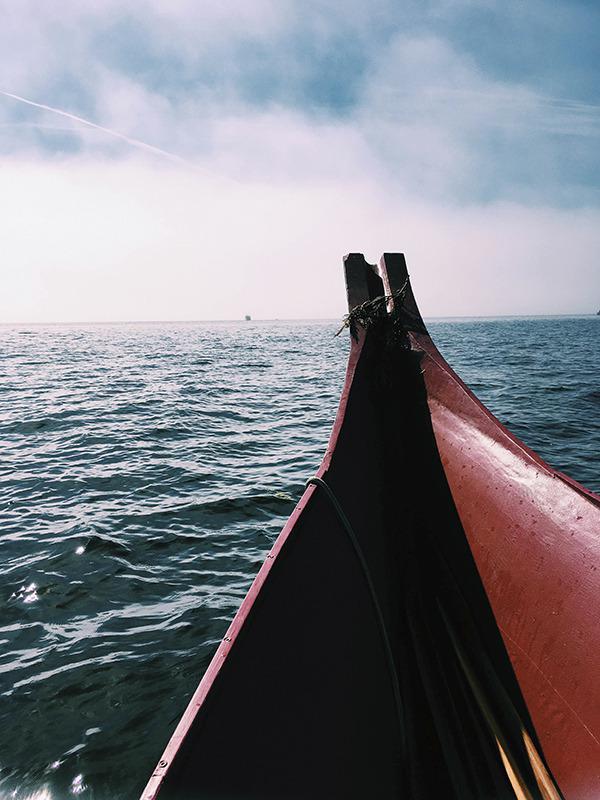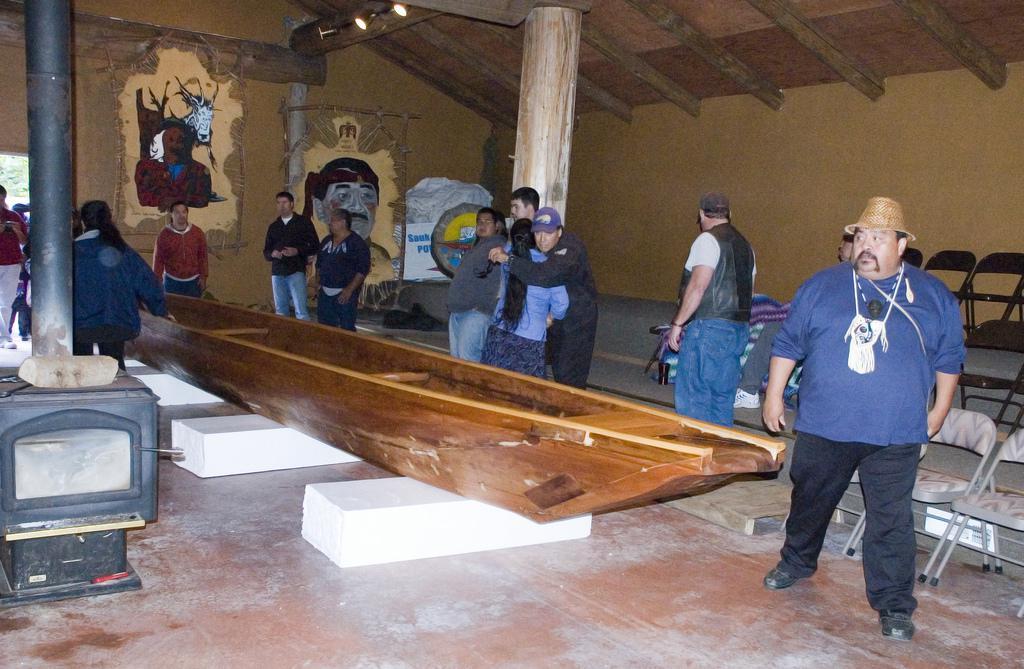The first image is the image on the left, the second image is the image on the right. Assess this claim about the two images: "An image shows the tips of at least two reddish-brown boats that are pulled to shore and overlooking the water.". Correct or not? Answer yes or no. No. The first image is the image on the left, the second image is the image on the right. Considering the images on both sides, is "In at least one image there are at least three empty boats." valid? Answer yes or no. No. 